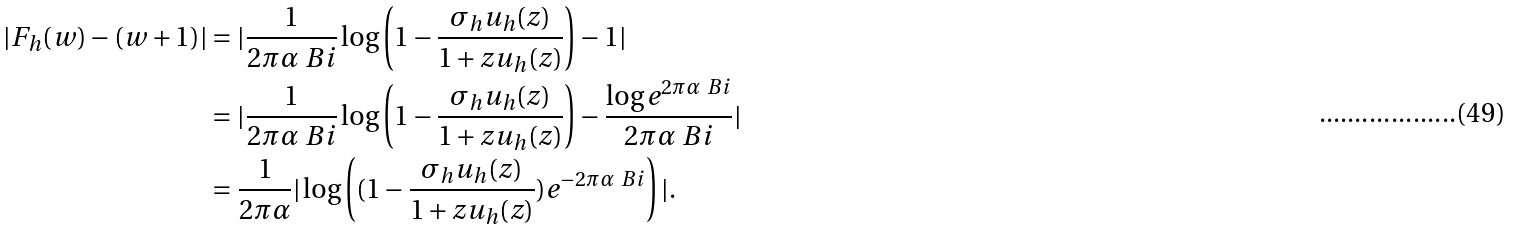Convert formula to latex. <formula><loc_0><loc_0><loc_500><loc_500>| F _ { h } ( w ) - ( w + 1 ) | & = | \frac { 1 } { 2 \pi \alpha \ B i } \log \left ( 1 - \frac { \sigma _ { h } u _ { h } ( z ) } { 1 + z u _ { h } ( z ) } \right ) - 1 | \\ & = | \frac { 1 } { 2 \pi \alpha \ B i } \log \left ( 1 - \frac { \sigma _ { h } u _ { h } ( z ) } { 1 + z u _ { h } ( z ) } \right ) - \frac { \log e ^ { 2 \pi \alpha \ B i } } { 2 \pi \alpha \ B i } | \\ & = \frac { 1 } { 2 \pi \alpha } | \log \left ( ( 1 - \frac { \sigma _ { h } u _ { h } ( z ) } { 1 + z u _ { h } ( z ) } ) e ^ { - 2 \pi \alpha \ B i } \right ) | .</formula> 